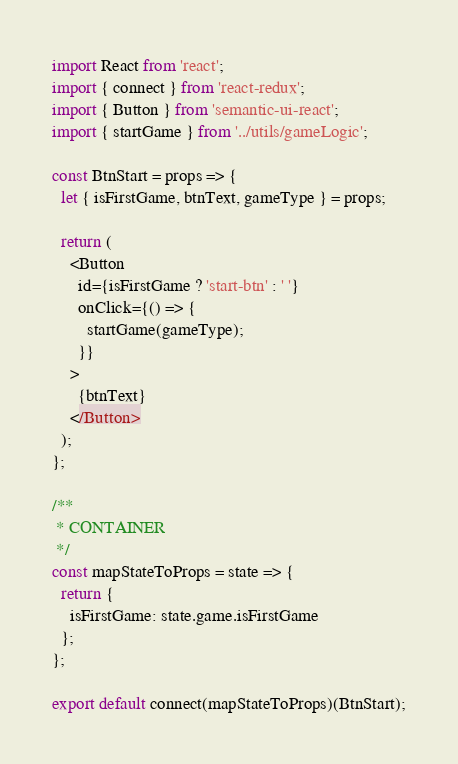<code> <loc_0><loc_0><loc_500><loc_500><_JavaScript_>import React from 'react';
import { connect } from 'react-redux';
import { Button } from 'semantic-ui-react';
import { startGame } from '../utils/gameLogic';

const BtnStart = props => {
  let { isFirstGame, btnText, gameType } = props;

  return (
    <Button
      id={isFirstGame ? 'start-btn' : ' '}
      onClick={() => {
        startGame(gameType);
      }}
    >
      {btnText}
    </Button>
  );
};

/**
 * CONTAINER
 */
const mapStateToProps = state => {
  return {
    isFirstGame: state.game.isFirstGame
  };
};

export default connect(mapStateToProps)(BtnStart);
</code> 